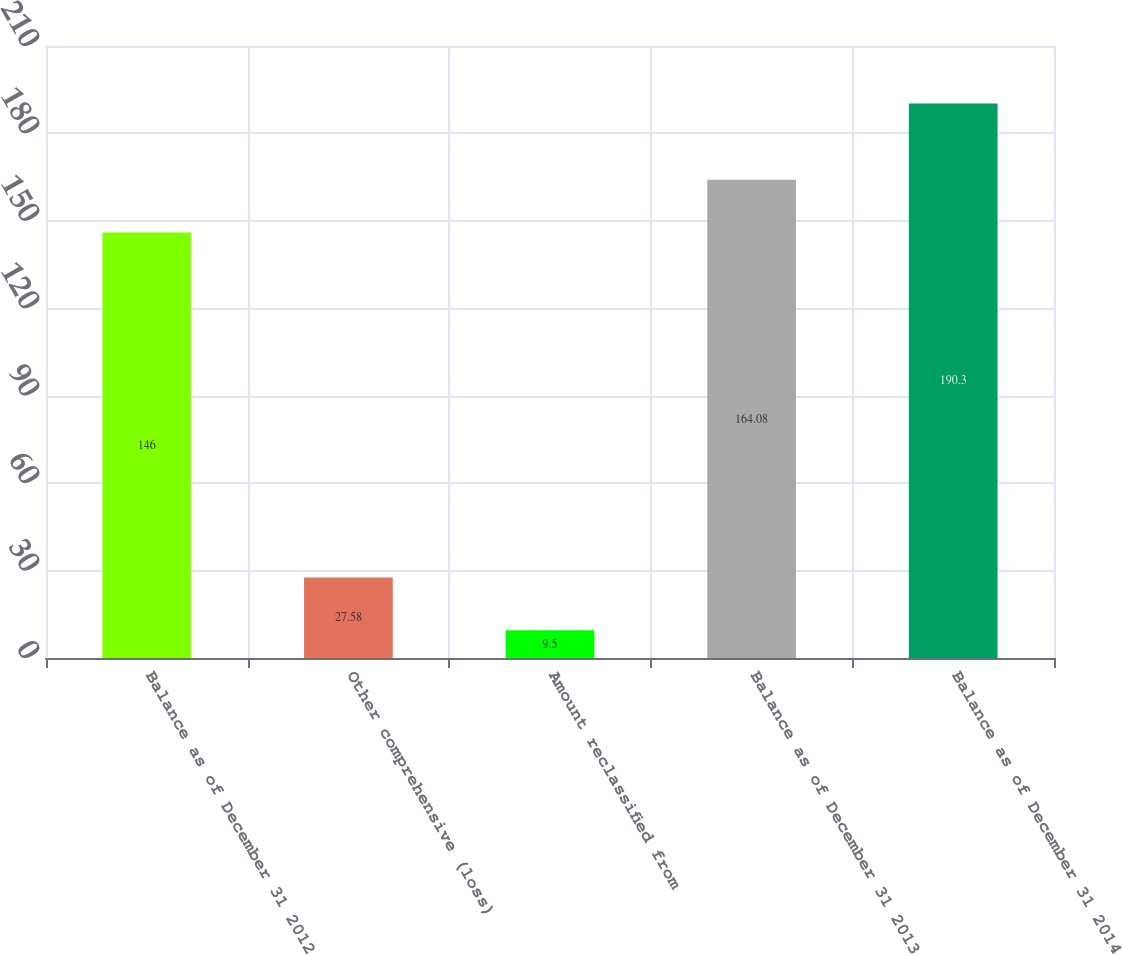Convert chart to OTSL. <chart><loc_0><loc_0><loc_500><loc_500><bar_chart><fcel>Balance as of December 31 2012<fcel>Other comprehensive (loss)<fcel>Amount reclassified from<fcel>Balance as of December 31 2013<fcel>Balance as of December 31 2014<nl><fcel>146<fcel>27.58<fcel>9.5<fcel>164.08<fcel>190.3<nl></chart> 